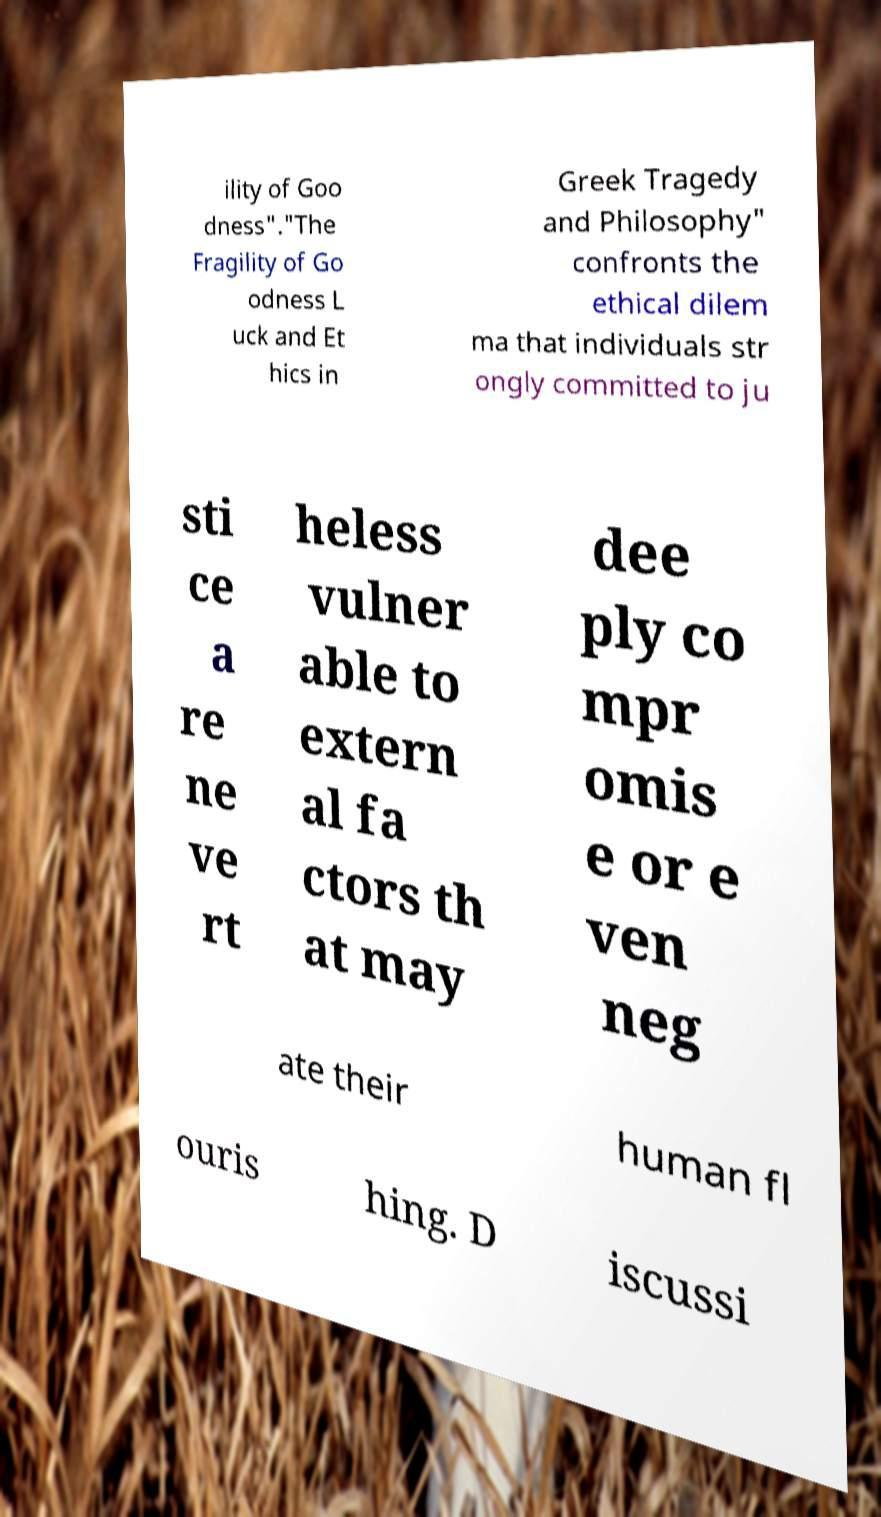There's text embedded in this image that I need extracted. Can you transcribe it verbatim? ility of Goo dness"."The Fragility of Go odness L uck and Et hics in Greek Tragedy and Philosophy" confronts the ethical dilem ma that individuals str ongly committed to ju sti ce a re ne ve rt heless vulner able to extern al fa ctors th at may dee ply co mpr omis e or e ven neg ate their human fl ouris hing. D iscussi 